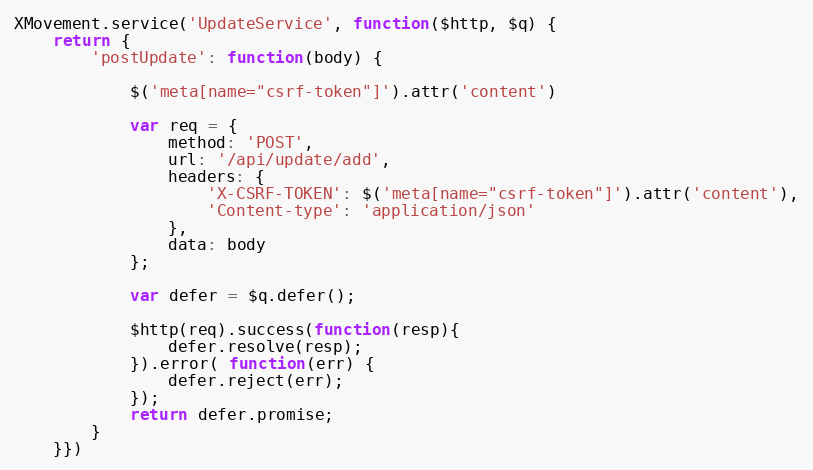<code> <loc_0><loc_0><loc_500><loc_500><_JavaScript_>XMovement.service('UpdateService', function($http, $q) {
	return {
		'postUpdate': function(body) {

			$('meta[name="csrf-token"]').attr('content')

			var req = {
				method: 'POST',
				url: '/api/update/add',
				headers: {
					'X-CSRF-TOKEN': $('meta[name="csrf-token"]').attr('content'),
		        	'Content-type': 'application/json'
				},
				data: body
			};

			var defer = $q.defer();
			
			$http(req).success(function(resp){
				defer.resolve(resp);
			}).error( function(err) {
				defer.reject(err);
			});
			return defer.promise;
		}
	}})
</code> 